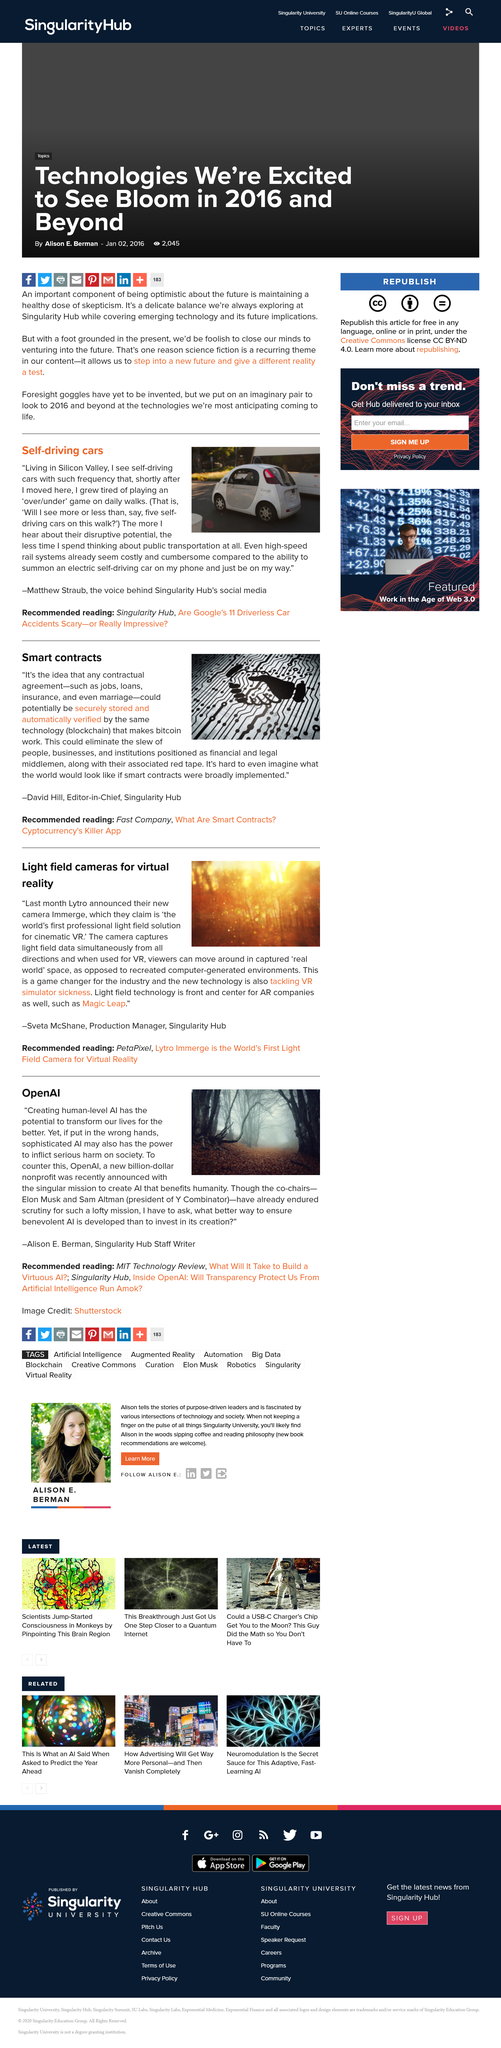Give some essential details in this illustration. The technology that enables the smooth functioning of bitcoin is blockchain. The voice behind the Singularity Hub's social media is Matthew Straub. Matthew Straub lives in Silicon Valley. Marriage could be stored as a smart contract, according to a declaration. The recommended reading in the above discussion includes articles from Singularity Hub and an article titled "Are Google’s 11 Driverless Car Accidents Scary - or Really Impressive? 